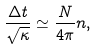Convert formula to latex. <formula><loc_0><loc_0><loc_500><loc_500>\frac { \Delta t } { \sqrt { \kappa } } \simeq \frac { N } { 4 \pi } n ,</formula> 